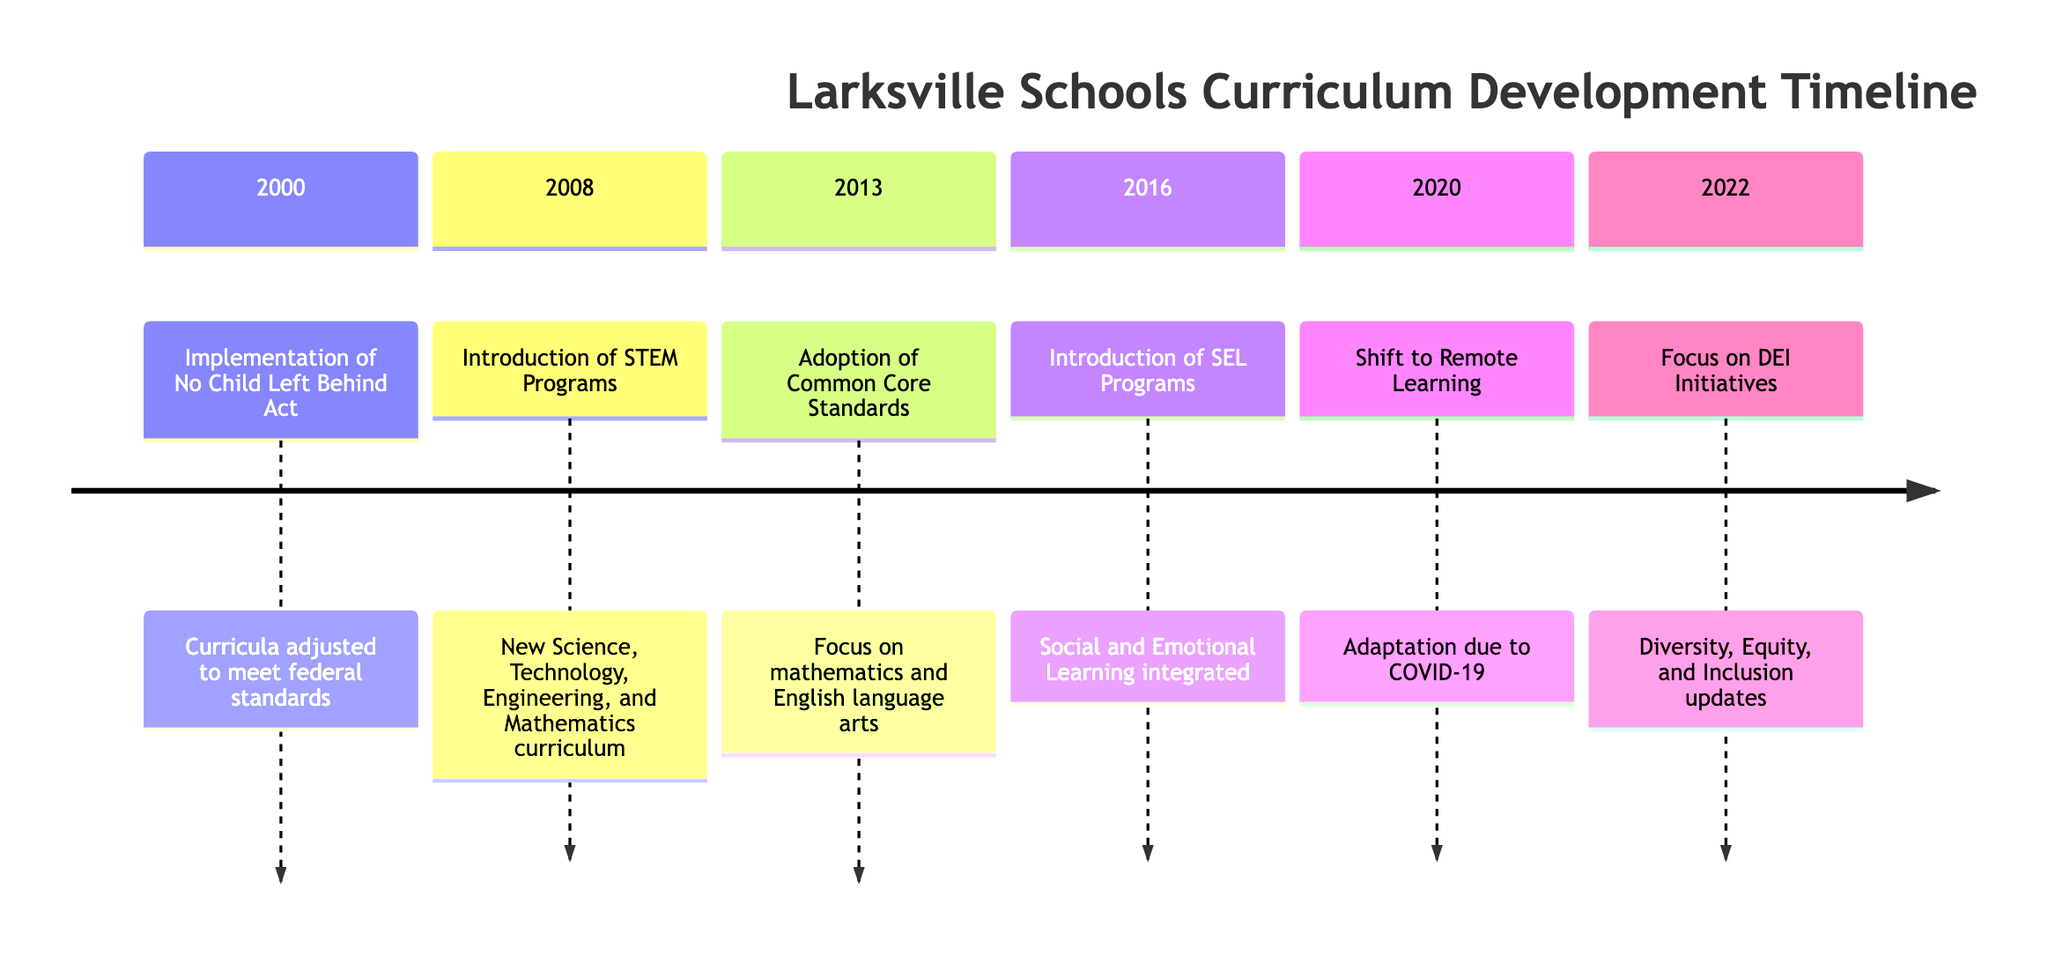What year did Larksville implement the No Child Left Behind Act? The timeline clearly states that the No Child Left Behind Act was implemented in the year 2000.
Answer: 2000 How many phases were involved in the introduction of STEM programs? The event for STEM programs in 2008 lists three phases: Curriculum Development, Pilot Programs, and Full Scale Implementation. Counting these gives a total of three phases.
Answer: 3 What significant educational change occurred in Larksville schools in 2016? The timeline specifies that the significant change in 2016 was the introduction of Social and Emotional Learning (SEL) programs integrated into the curriculum.
Answer: Introduction of SEL Programs What are the primary community concerns regarding the shift to remote learning in 2020? The timeline notes that community feedback included concerns about accessibility and equity related to remote learning due to COVID-19.
Answer: Accessibility and equity In what year did Larksville schools focus on Diversity, Equity, and Inclusion initiatives? The timeline indicates that the focus on DEI initiatives began in 2022. Hence, the year of this focus is 2022.
Answer: 2022 What was the community response to the introduction of SEL programs in 2016? According to the diagram, the community feedback for SEL programs included strong support for the focus on mental health.
Answer: Strong support for mental health Which curriculum update followed the adoption of Common Core Standards in 2013? Looking at the timeline, it is evident that the next major update after the Common Core Standards was the introduction of Social and Emotional Learning (SEL) programs in 2016.
Answer: Introduction of SEL Programs What was the purpose of the staff training phase in the Common Core Standards transition? The staff training phase was aimed at preparing educators for the transition to Common Core Standards, as listed in the phases of implementation in 2013.
Answer: Prepare educators How many events are detailed in the timeline? By counting the listed events - from the implementation of No Child Left Behind Act in 2000 to the focus on DEI initiatives in 2022, there are six distinct events represented in the timeline.
Answer: 6 